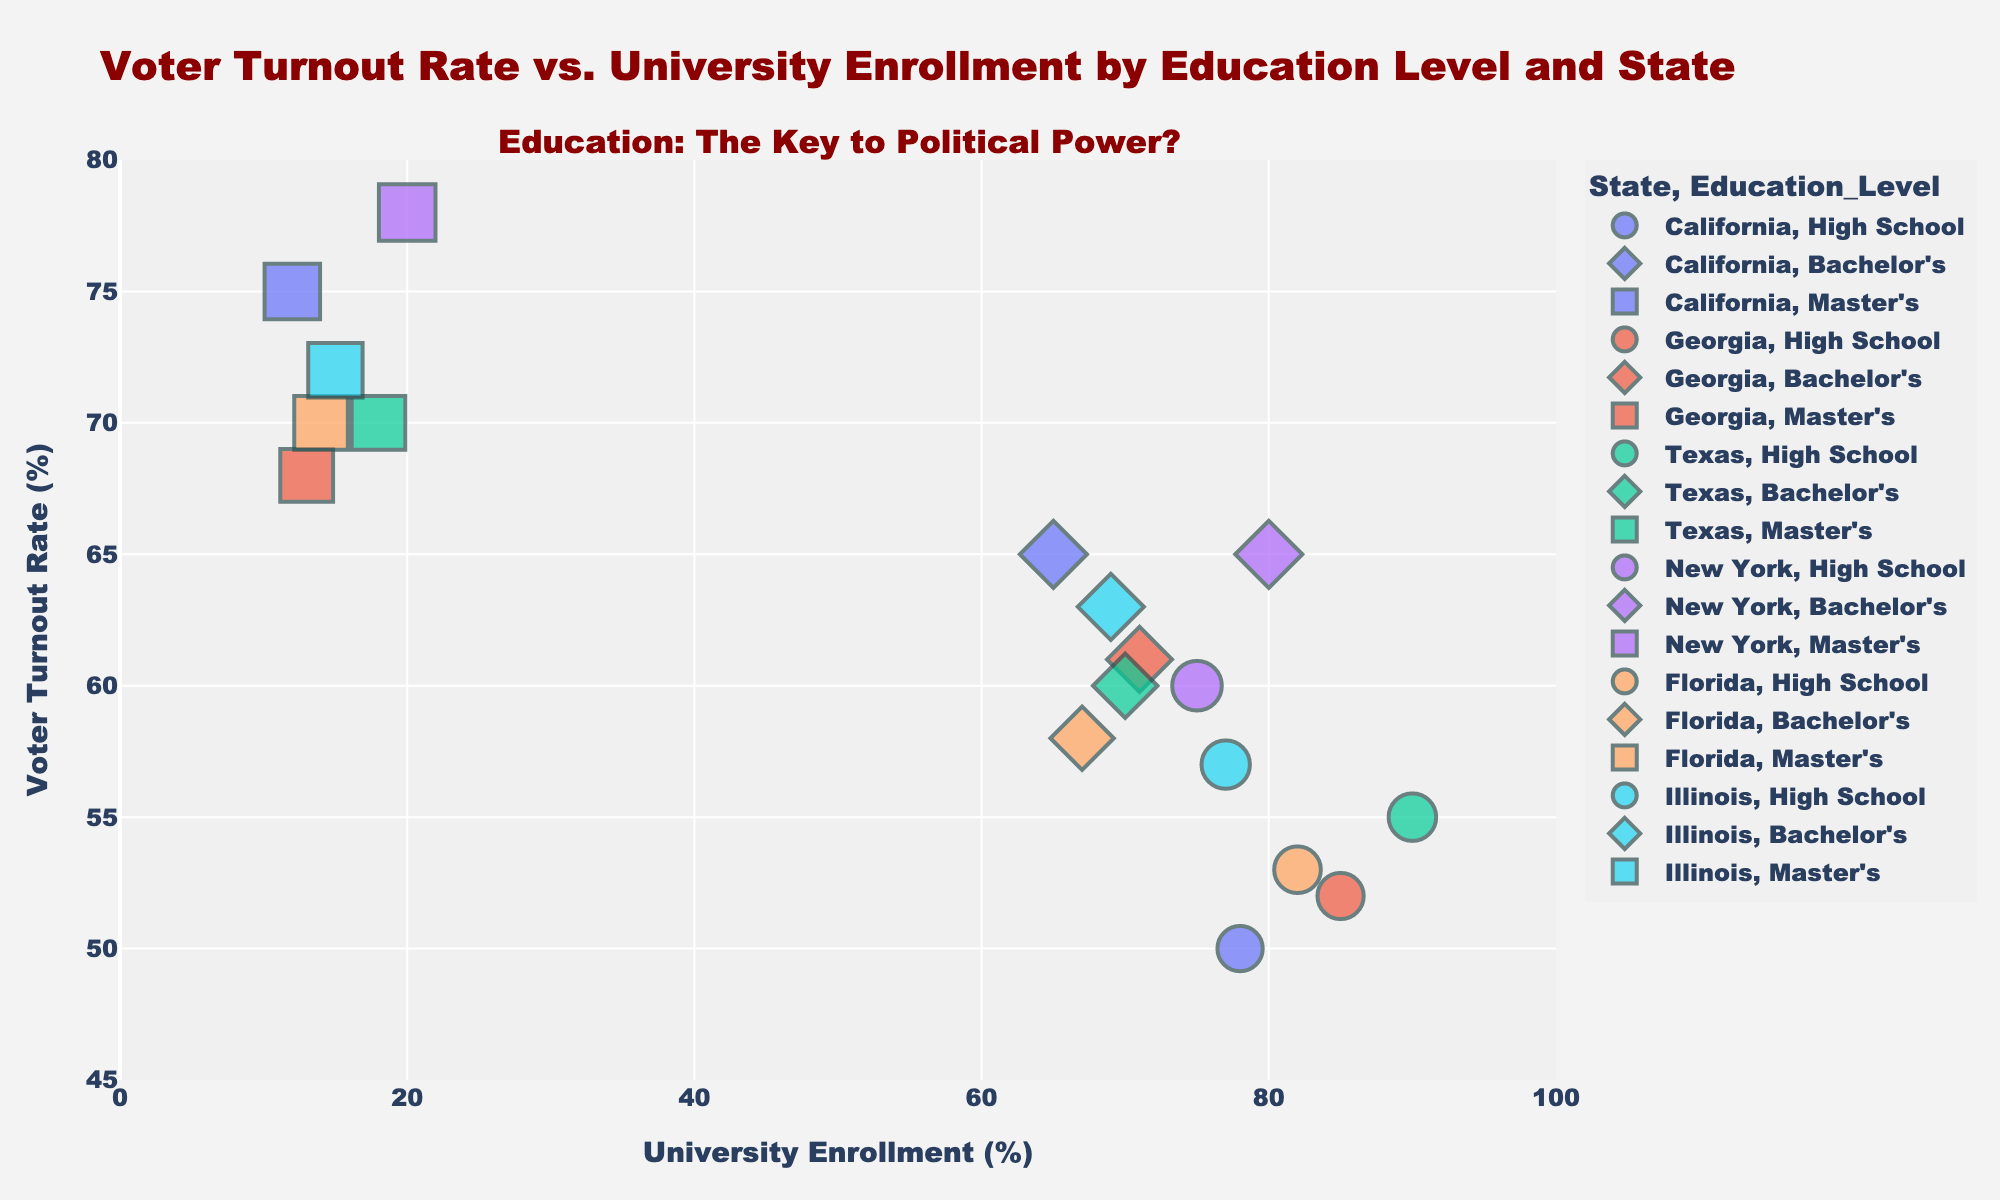What is the title of the scatter plot? The title is located at the top of the scatter plot. To answer this, we look at the heading text.
Answer: Voter Turnout Rate vs. University Enrollment by Education Level and State How many education levels are distinguished in the plot? Identify the number of unique symbols. The legend indicates three categories of education levels.
Answer: Three What color represents the data points for New York? Check the legend in the plot to see which color is associated with New York.
Answer: Blue Which State has the highest point for Voter Turnout Rate? Identify the data point with the highest y-axis value and refer to its associated state.
Answer: New York Which education level tends to have a higher voter turnout rate? Assess the relative positions of the different symbols representing education levels along the y-axis. Symbols for Master's are generally higher on the axis
Answer: Master’s For Texas, what is the Voter Turnout Rate for Bachelor’s level education? Locate Texas in the legend, then find the corresponding symbol for Bachelor’s level and read the y-axis value.
Answer: 60 Comparing California and Texas, which state shows a higher overall voter turnout rate for Master’s level education? Look at the data points for Master’s education (star symbol) for both California and Texas and compare their y-axis values.
Answer: California What does the annotation at the top of the plot suggest? Read the text annotation at the top of the plot.
Answer: Education: The Key to Political Power? Which state has the widest range of Voter Turnout Rates across different education levels? Compare the spread of y-axis values within each state. New York has points from 60% to 78% indicating the widest range.
Answer: New York Is there a general trend between University Enrollment and Voter Turnout Rate across the states? Observe whether the data points form a pattern or relationship between the x-axis (University Enrollment) and y-axis (Voter Turnout Rate). Higher education generally correlates with higher voter turnout.
Answer: Positive trend 